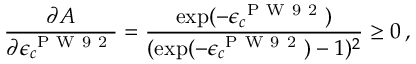Convert formula to latex. <formula><loc_0><loc_0><loc_500><loc_500>\frac { \partial A } { \partial \epsilon _ { c } ^ { P W 9 2 } } = \frac { \exp ( - \epsilon _ { c } ^ { P W 9 2 } ) } { ( \exp ( - \epsilon _ { c } ^ { P W 9 2 } ) - 1 ) ^ { 2 } } \geq 0 \, ,</formula> 